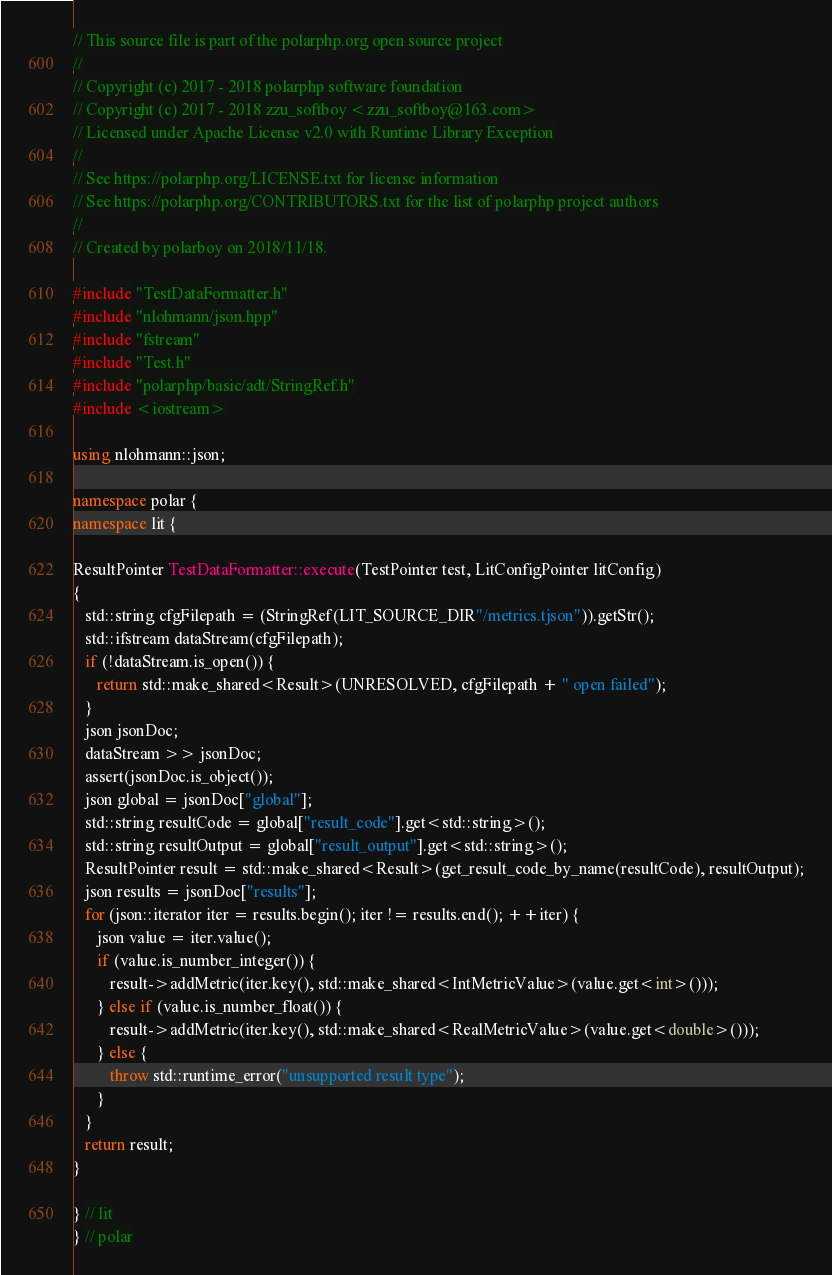Convert code to text. <code><loc_0><loc_0><loc_500><loc_500><_C++_>// This source file is part of the polarphp.org open source project
//
// Copyright (c) 2017 - 2018 polarphp software foundation
// Copyright (c) 2017 - 2018 zzu_softboy <zzu_softboy@163.com>
// Licensed under Apache License v2.0 with Runtime Library Exception
//
// See https://polarphp.org/LICENSE.txt for license information
// See https://polarphp.org/CONTRIBUTORS.txt for the list of polarphp project authors
//
// Created by polarboy on 2018/11/18.

#include "TestDataFormatter.h"
#include "nlohmann/json.hpp"
#include "fstream"
#include "Test.h"
#include "polarphp/basic/adt/StringRef.h"
#include <iostream>

using nlohmann::json;

namespace polar {
namespace lit {

ResultPointer TestDataFormatter::execute(TestPointer test, LitConfigPointer litConfig)
{
   std::string cfgFilepath = (StringRef(LIT_SOURCE_DIR"/metrics.tjson")).getStr();
   std::ifstream dataStream(cfgFilepath);
   if (!dataStream.is_open()) {
      return std::make_shared<Result>(UNRESOLVED, cfgFilepath + " open failed");
   }
   json jsonDoc;
   dataStream >> jsonDoc;
   assert(jsonDoc.is_object());
   json global = jsonDoc["global"];
   std::string resultCode = global["result_code"].get<std::string>();
   std::string resultOutput = global["result_output"].get<std::string>();
   ResultPointer result = std::make_shared<Result>(get_result_code_by_name(resultCode), resultOutput);
   json results = jsonDoc["results"];
   for (json::iterator iter = results.begin(); iter != results.end(); ++iter) {
      json value = iter.value();
      if (value.is_number_integer()) {
         result->addMetric(iter.key(), std::make_shared<IntMetricValue>(value.get<int>()));
      } else if (value.is_number_float()) {
         result->addMetric(iter.key(), std::make_shared<RealMetricValue>(value.get<double>()));
      } else {
         throw std::runtime_error("unsupported result type");
      }
   }
   return result;
}

} // lit
} // polar
</code> 